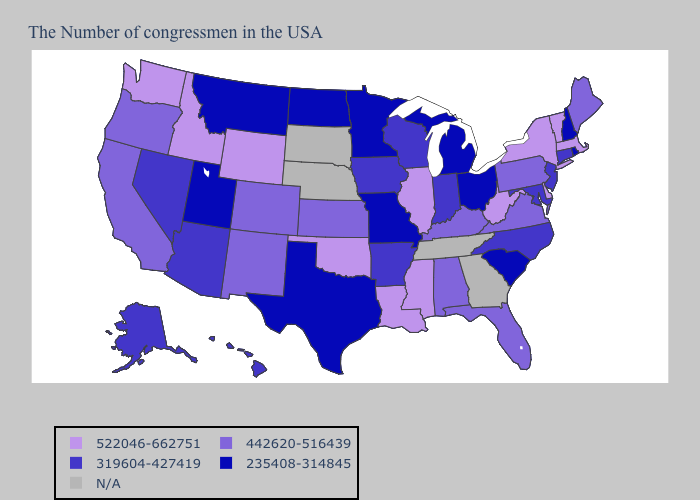Name the states that have a value in the range 522046-662751?
Give a very brief answer. Massachusetts, Vermont, New York, Delaware, West Virginia, Illinois, Mississippi, Louisiana, Oklahoma, Wyoming, Idaho, Washington. What is the lowest value in the USA?
Give a very brief answer. 235408-314845. What is the value of Alaska?
Write a very short answer. 319604-427419. Among the states that border Pennsylvania , does New Jersey have the highest value?
Concise answer only. No. Among the states that border Texas , does New Mexico have the lowest value?
Be succinct. No. Does the first symbol in the legend represent the smallest category?
Answer briefly. No. What is the highest value in states that border North Dakota?
Keep it brief. 235408-314845. Name the states that have a value in the range 522046-662751?
Write a very short answer. Massachusetts, Vermont, New York, Delaware, West Virginia, Illinois, Mississippi, Louisiana, Oklahoma, Wyoming, Idaho, Washington. Name the states that have a value in the range 442620-516439?
Short answer required. Maine, Pennsylvania, Virginia, Florida, Kentucky, Alabama, Kansas, Colorado, New Mexico, California, Oregon. Name the states that have a value in the range 442620-516439?
Keep it brief. Maine, Pennsylvania, Virginia, Florida, Kentucky, Alabama, Kansas, Colorado, New Mexico, California, Oregon. What is the lowest value in states that border Maryland?
Short answer required. 442620-516439. How many symbols are there in the legend?
Write a very short answer. 5. What is the value of South Carolina?
Answer briefly. 235408-314845. 